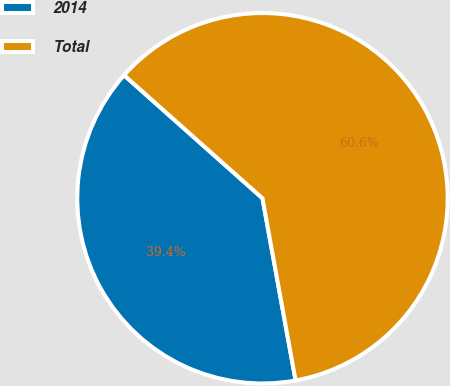Convert chart. <chart><loc_0><loc_0><loc_500><loc_500><pie_chart><fcel>2014<fcel>Total<nl><fcel>39.43%<fcel>60.57%<nl></chart> 